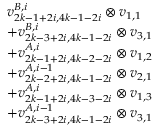<formula> <loc_0><loc_0><loc_500><loc_500>\begin{array} { r l } & { v _ { 2 k - 1 + 2 i , 4 k - 1 - 2 i } ^ { B , i } \otimes v _ { 1 , 1 } } \\ & { + v _ { 2 k - 3 + 2 i , 4 k - 1 - 2 i } ^ { B , i } \otimes v _ { 3 , 1 } } \\ & { + v _ { 2 k - 1 + 2 i , 4 k - 2 - 2 i } ^ { A , i } \otimes v _ { 1 , 2 } } \\ & { + v _ { 2 k - 2 + 2 i , 4 k - 1 - 2 i } ^ { A , i - 1 } \otimes v _ { 2 , 1 } } \\ & { + v _ { 2 k - 1 + 2 i , 4 k - 3 - 2 i } ^ { A , i } \otimes v _ { 1 , 3 } } \\ & { + v _ { 2 k - 3 + 2 i , 4 k - 1 - 2 i } ^ { A , i - 1 } \otimes v _ { 3 , 1 } } \end{array}</formula> 